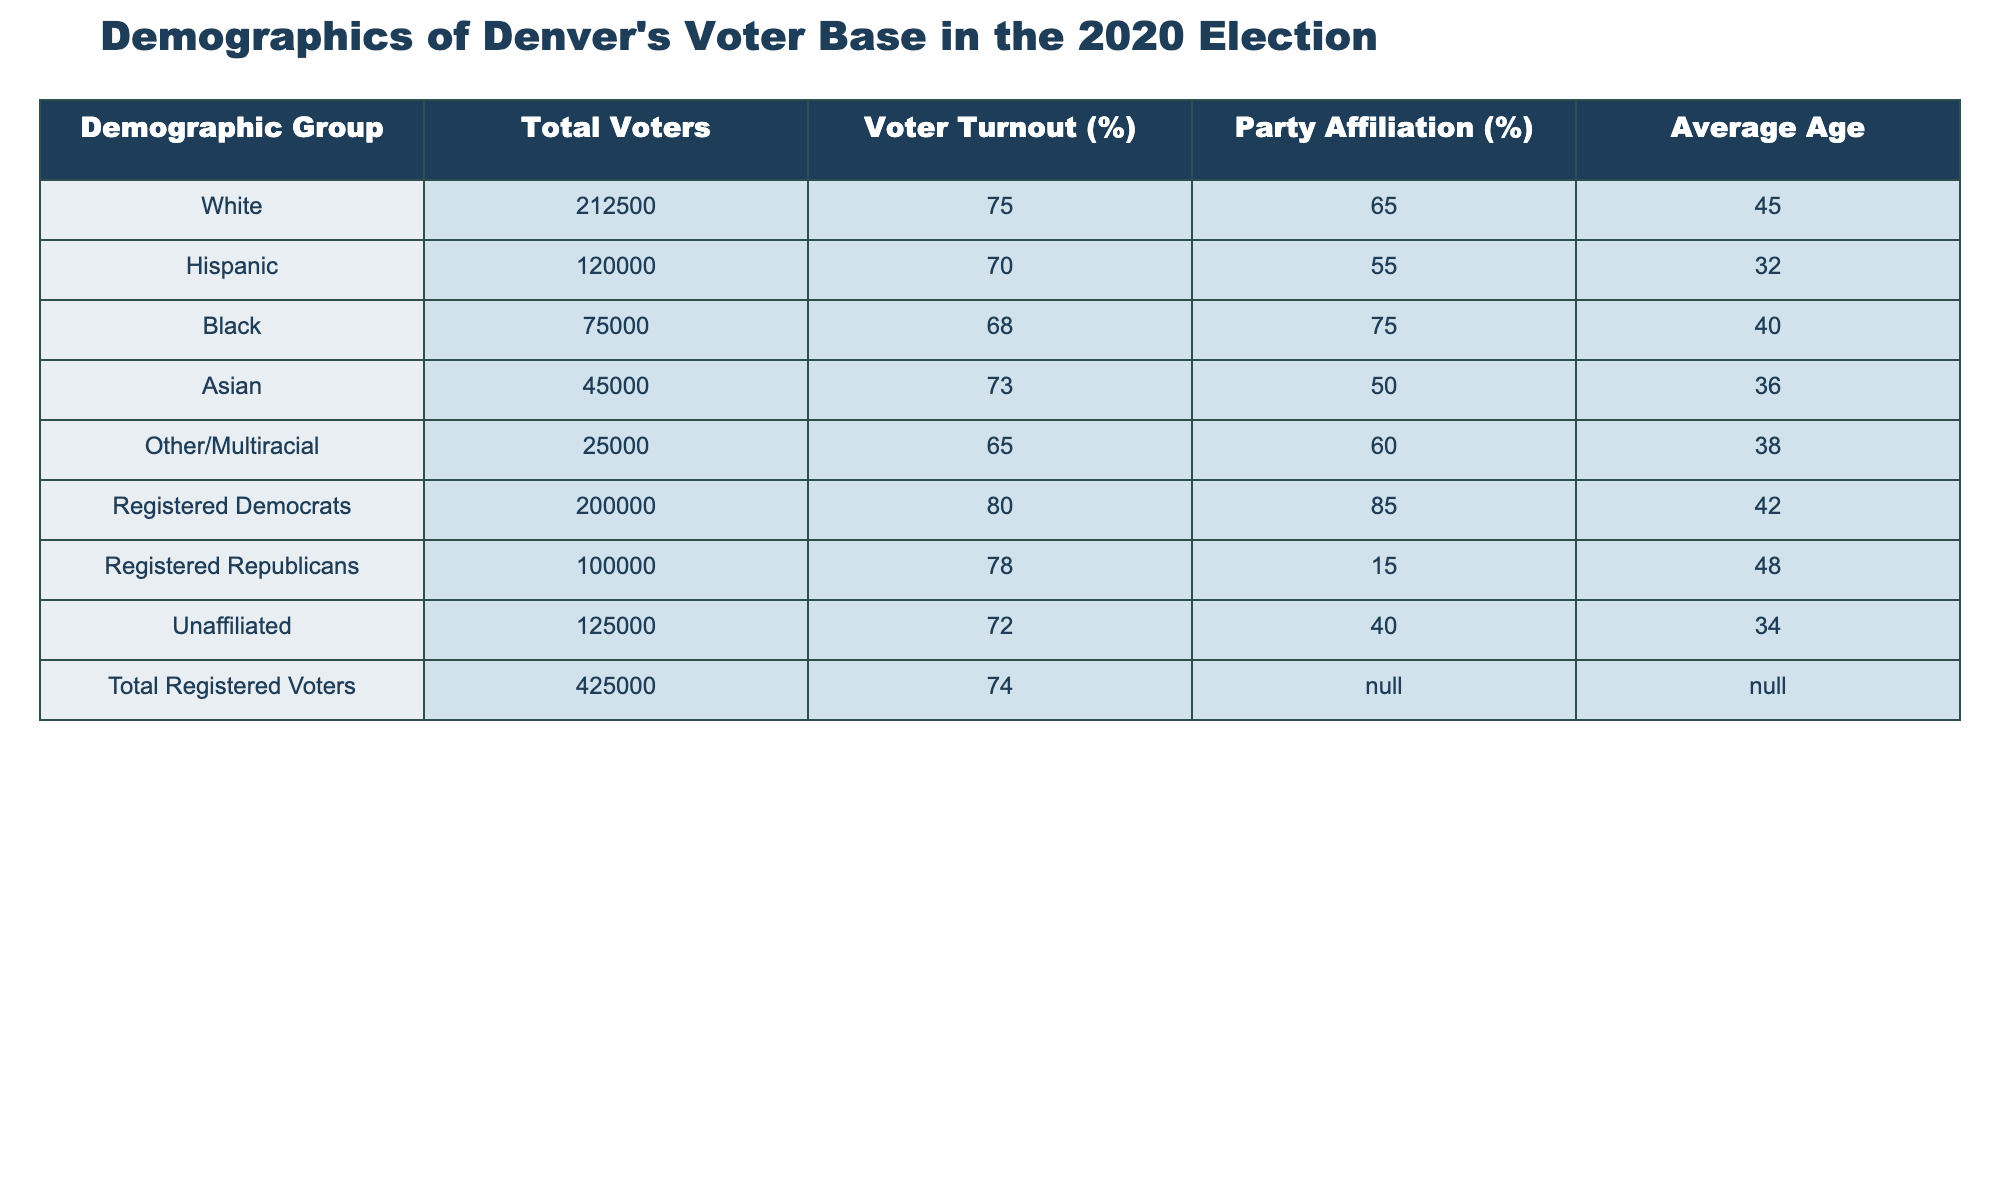What was the voter turnout percentage for White voters? The table shows that the voter turnout percentage for White voters is listed under the "Voter Turnout (%)" column next to "White", which is 75%.
Answer: 75% Which demographic group had the lowest average age? By comparing the "Average Age" values for each demographic group, we see that the Hispanic group has the lowest average age of 32 years.
Answer: 32 What is the total number of registered Democrats? The total number of registered Democrats is specified in the "Total Voters" column under "Registered Democrats", which is 200,000.
Answer: 200000 What percentage of Black voters identified as registered Democrats? To find this, we can refer to the "Party Affiliation (%)" for Black voters, which is 75%. This is the percentage that identified as Democrats.
Answer: 75% What is the total number of voters who are not registered Democrats? The total number of voters who are not registered Democrats can be calculated by subtracting the number of registered Democrats (200,000) from the total number of registered voters (425,000), which is 225,000.
Answer: 225000 Which demographic group had the highest voter turnout? By examining the "Voter Turnout (%)" for each group, we find that registered Democrats had the highest voter turnout at 80%.
Answer: 80% Is it true that Asian voters had a higher voter turnout than Hispanic voters? Looking at the respective percentages in the "Voter Turnout (%)" column, Asian voters had a turnout of 73% while Hispanic voters had a turnout of 70%. Therefore, it is true that Asian voters had a higher turnout.
Answer: Yes What is the average age of the Unaffiliated voters? The average age is provided under the "Average Age" column for Unaffiliated voters, which is 34 years old.
Answer: 34 What demographic group has the highest percentage of Republican affiliation? By reviewing the "Party Affiliation (%)" column, we see that Registered Republicans have 15%, which is the highest percentage for that party affiliation listed.
Answer: 15% What is the difference in voter turnout between Registered Democrats and Registered Republicans? The voter turnout for Registered Democrats is 80% and for Registered Republicans it is 78%. The difference is calculated as 80% - 78% = 2%.
Answer: 2% 